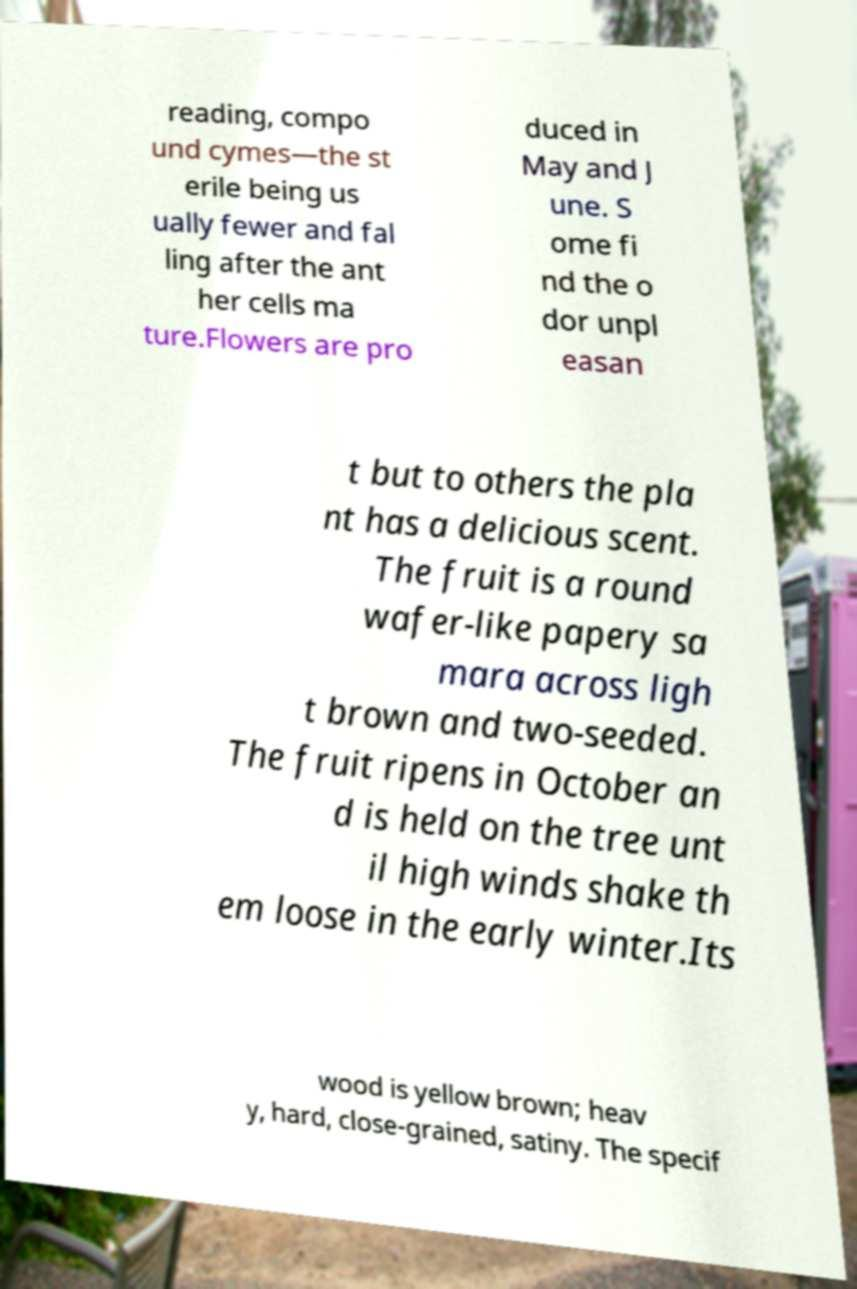Could you extract and type out the text from this image? reading, compo und cymes—the st erile being us ually fewer and fal ling after the ant her cells ma ture.Flowers are pro duced in May and J une. S ome fi nd the o dor unpl easan t but to others the pla nt has a delicious scent. The fruit is a round wafer-like papery sa mara across ligh t brown and two-seeded. The fruit ripens in October an d is held on the tree unt il high winds shake th em loose in the early winter.Its wood is yellow brown; heav y, hard, close-grained, satiny. The specif 